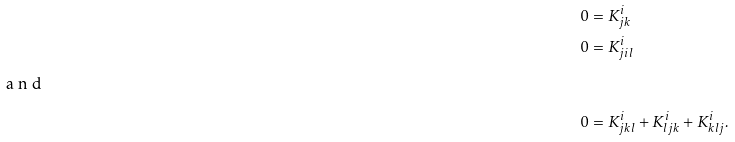<formula> <loc_0><loc_0><loc_500><loc_500>0 & = K ^ { i } _ { j k } \\ 0 & = K ^ { i } _ { j i l } \\ \intertext { a n d } 0 & = K ^ { i } _ { j k l } + K ^ { i } _ { l j k } + K ^ { i } _ { k l j } .</formula> 